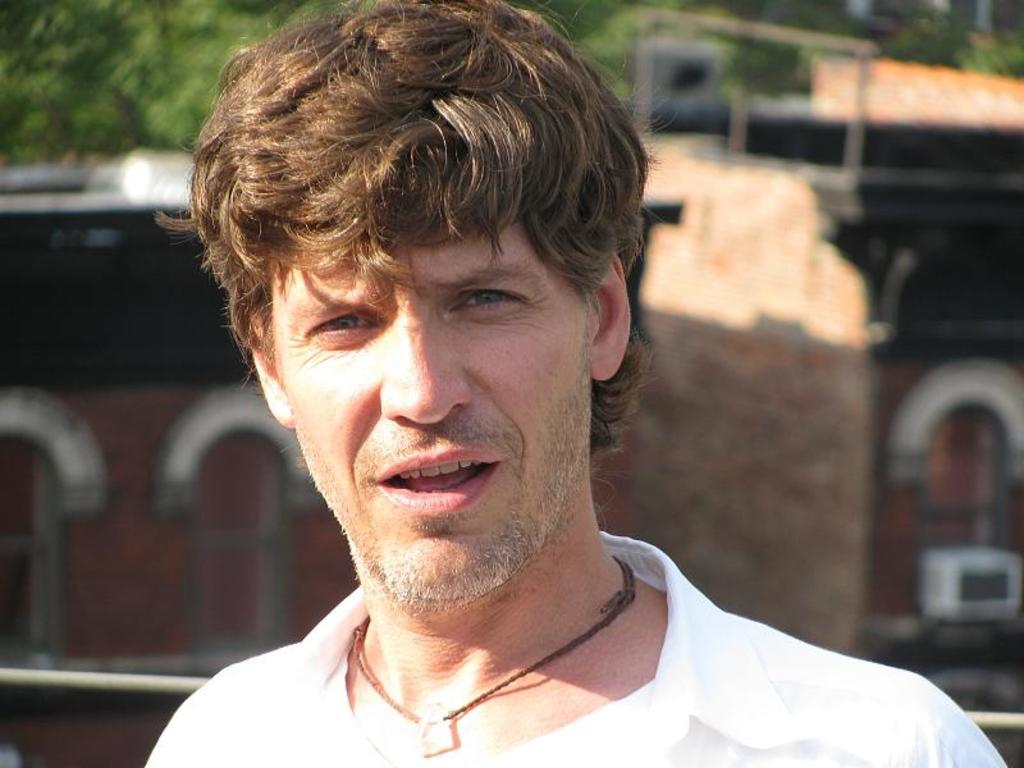Who or what is present in the image? There is a person in the image. What can be seen in the background behind the person? There are trees and buildings behind the person. What type of wool is being used by the person in the image? There is no wool present in the image, and the person's actions or clothing do not indicate the use of wool. 